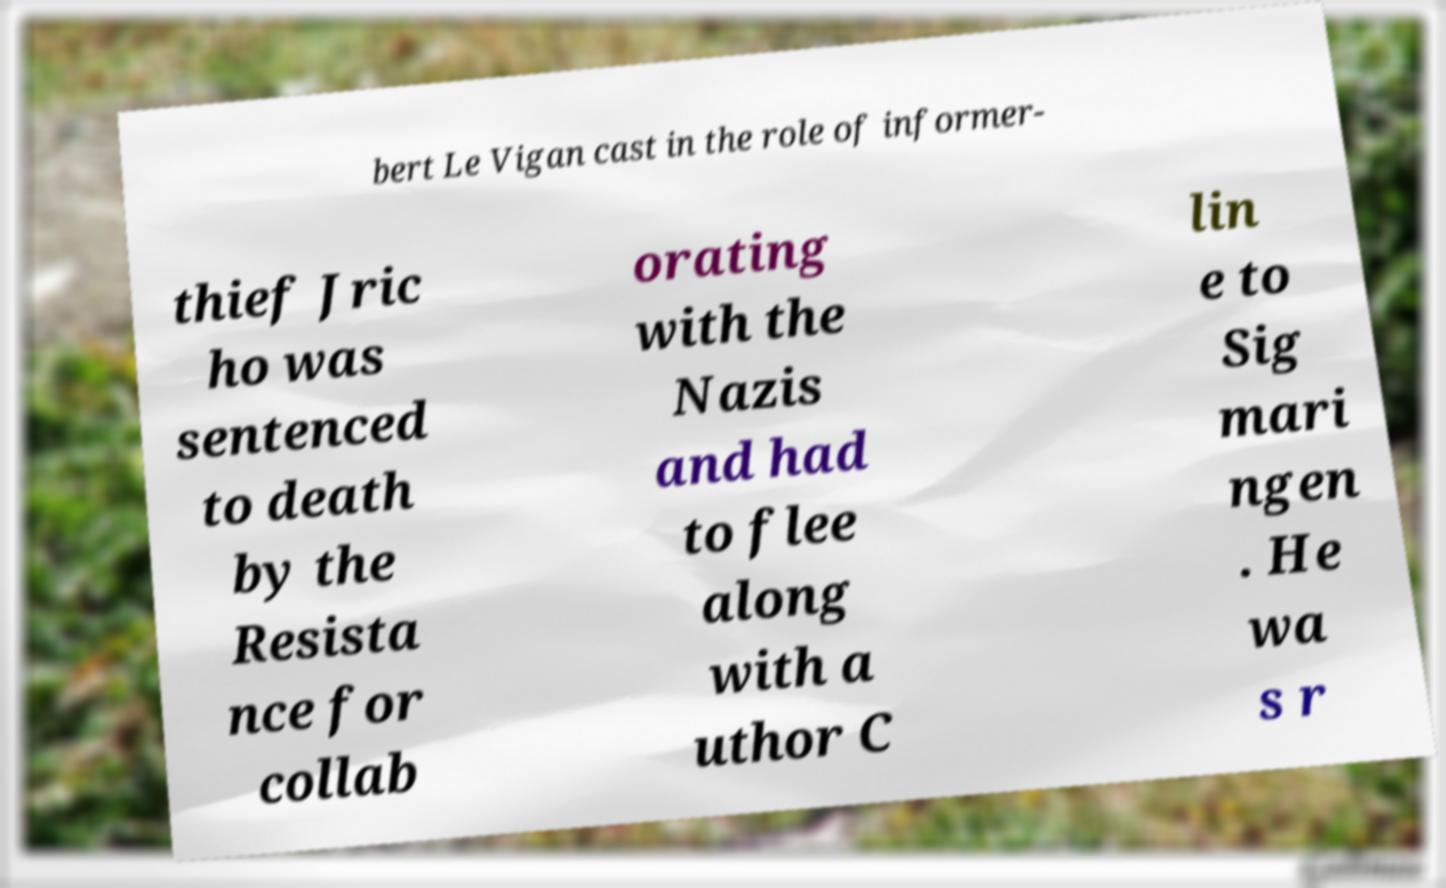What messages or text are displayed in this image? I need them in a readable, typed format. bert Le Vigan cast in the role of informer- thief Jric ho was sentenced to death by the Resista nce for collab orating with the Nazis and had to flee along with a uthor C lin e to Sig mari ngen . He wa s r 